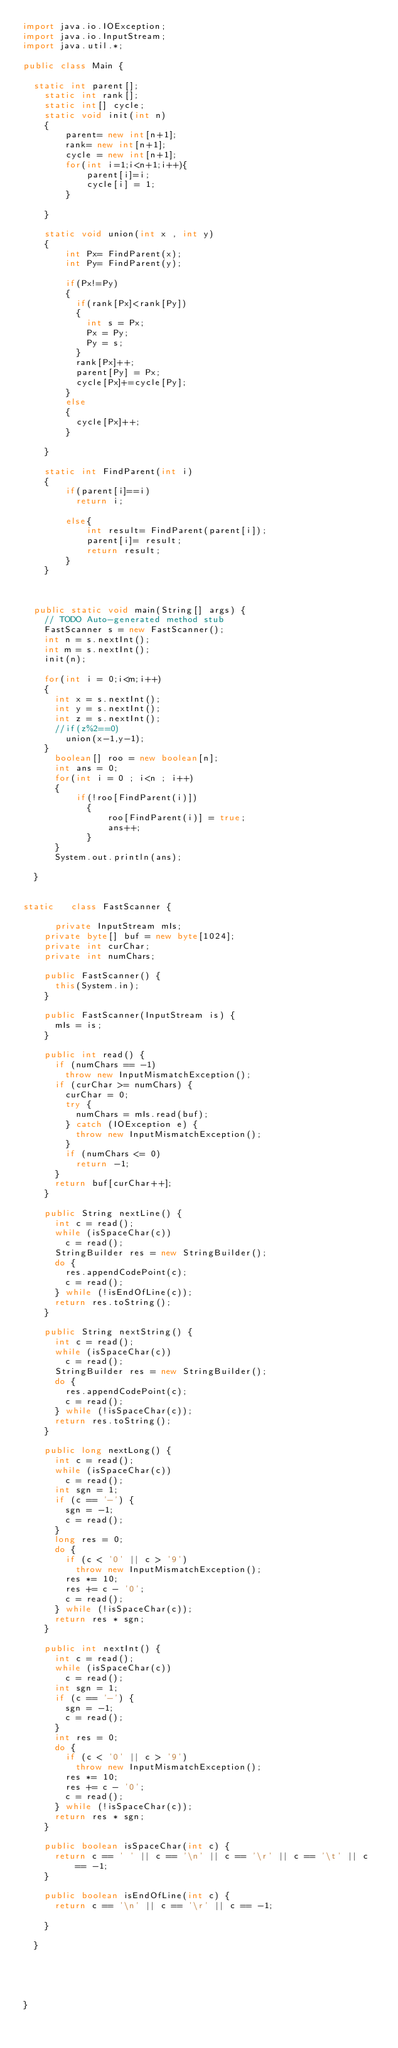<code> <loc_0><loc_0><loc_500><loc_500><_Java_>import java.io.IOException;
import java.io.InputStream;
import java.util.*;

public class Main {

	static int parent[];
    static int rank[];
    static int[] cycle;
    static void init(int n)
    {
        parent= new int[n+1];
        rank= new int[n+1];
        cycle = new int[n+1];
        for(int i=1;i<n+1;i++){
            parent[i]=i;
            cycle[i] = 1;
        }
        
    }
    
    static void union(int x , int y)
    {
        int Px= FindParent(x);
        int Py= FindParent(y);
        
        if(Px!=Py)
        {
        	if(rank[Px]<rank[Py])
        	{
        		int s = Px;
        		Px = Py;
        		Py = s;
        	}
        	rank[Px]++;
        	parent[Py] = Px;
        	cycle[Px]+=cycle[Py];
        }
        else
        {
        	cycle[Px]++;
        }
        
    }
    
    static int FindParent(int i)
    {
        if(parent[i]==i) 
        	return i;
        
        else{
            int result= FindParent(parent[i]);
            parent[i]= result;
            return result;
        }
    }

	
	
	public static void main(String[] args) {
		// TODO Auto-generated method stub
		FastScanner s = new FastScanner();
		int n = s.nextInt();
		int m = s.nextInt();
		init(n);
		
		for(int i = 0;i<m;i++)
		{
			int x = s.nextInt();
			int y = s.nextInt();
			int z = s.nextInt();
			//if(z%2==0)
				union(x-1,y-1);
		}
      boolean[] roo = new boolean[n];
      int ans = 0;
      for(int i = 0 ; i<n ; i++)
      {
        	if(!roo[FindParent(i)])
            {
              	roo[FindParent(i)] = true;
              	ans++;
            }
      }
      System.out.println(ans);
		
	}
	
	
static   class FastScanner {
		
	    private InputStream mIs;
		private byte[] buf = new byte[1024];
		private int curChar;
		private int numChars;

		public FastScanner() {
			this(System.in);
		}

		public FastScanner(InputStream is) {
			mIs = is;
		}

		public int read() {
			if (numChars == -1)
				throw new InputMismatchException();
			if (curChar >= numChars) {
				curChar = 0;
				try {
					numChars = mIs.read(buf);
				} catch (IOException e) {
					throw new InputMismatchException();
				}
				if (numChars <= 0)
					return -1;
			}
			return buf[curChar++];
		}

		public String nextLine() {
			int c = read();
			while (isSpaceChar(c))
				c = read();
			StringBuilder res = new StringBuilder();
			do {
				res.appendCodePoint(c);
				c = read();
			} while (!isEndOfLine(c));
			return res.toString();
		}

		public String nextString() {
			int c = read();
			while (isSpaceChar(c))
				c = read();
			StringBuilder res = new StringBuilder();
			do {
				res.appendCodePoint(c);
				c = read();
			} while (!isSpaceChar(c));
			return res.toString();
		}

		public long nextLong() {
			int c = read();
			while (isSpaceChar(c))
				c = read();
			int sgn = 1;
			if (c == '-') {
				sgn = -1;
				c = read();
			}
			long res = 0;
			do {
				if (c < '0' || c > '9')
					throw new InputMismatchException();
				res *= 10;
				res += c - '0';
				c = read();
			} while (!isSpaceChar(c));
			return res * sgn;
		}

		public int nextInt() {
			int c = read();
			while (isSpaceChar(c))
				c = read();
			int sgn = 1;
			if (c == '-') {
				sgn = -1;
				c = read();
			}
			int res = 0;
			do {
				if (c < '0' || c > '9')
					throw new InputMismatchException();
				res *= 10;
				res += c - '0';
				c = read();
			} while (!isSpaceChar(c));
			return res * sgn;
		}

		public boolean isSpaceChar(int c) {
			return c == ' ' || c == '\n' || c == '\r' || c == '\t' || c == -1;
		}

		public boolean isEndOfLine(int c) {
			return c == '\n' || c == '\r' || c == -1;
		
		}	

	}

	
	
	

}</code> 